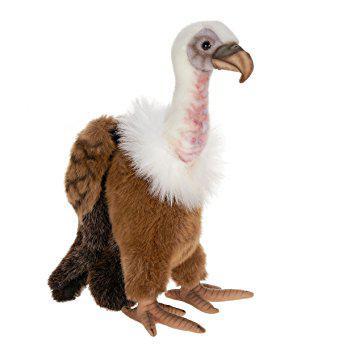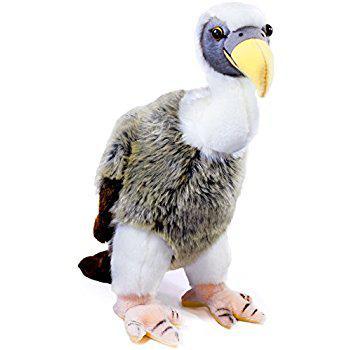The first image is the image on the left, the second image is the image on the right. Given the left and right images, does the statement "1 bird is facing left and 1 bird is facing right." hold true? Answer yes or no. No. 